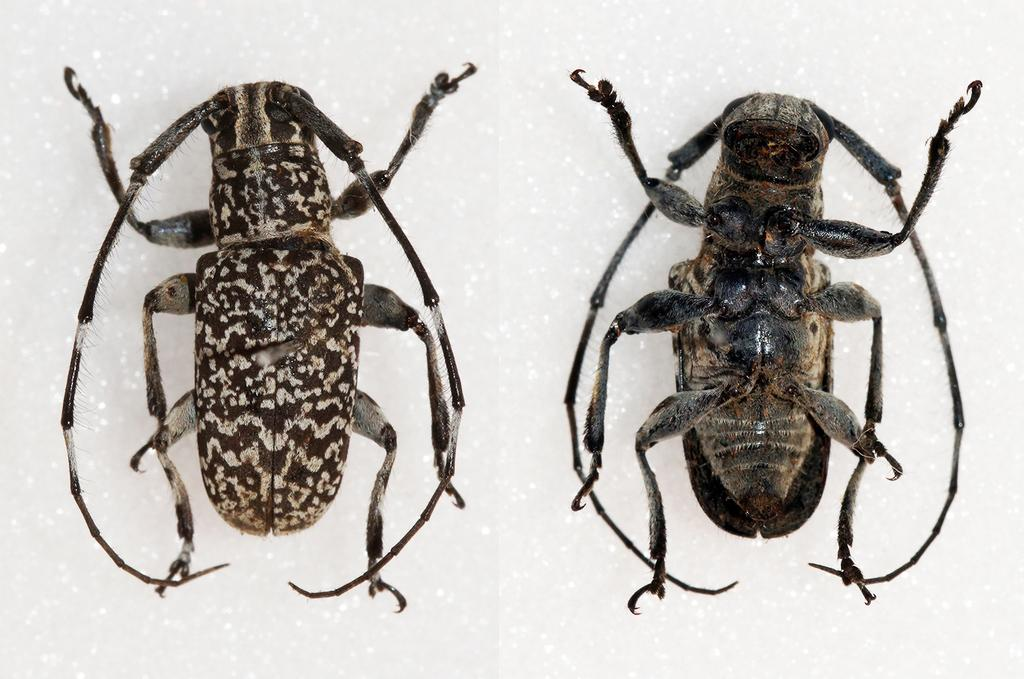What type of creatures can be seen in the image? There are two insects in the image. What color is the background of the image? The background of the image is white in color. How many geese are present in the image? There are no geese present in the image; it features two insects. What type of nut can be seen being smashed by the insects in the image? There is no nut present in the image, nor are the insects smashing anything. 